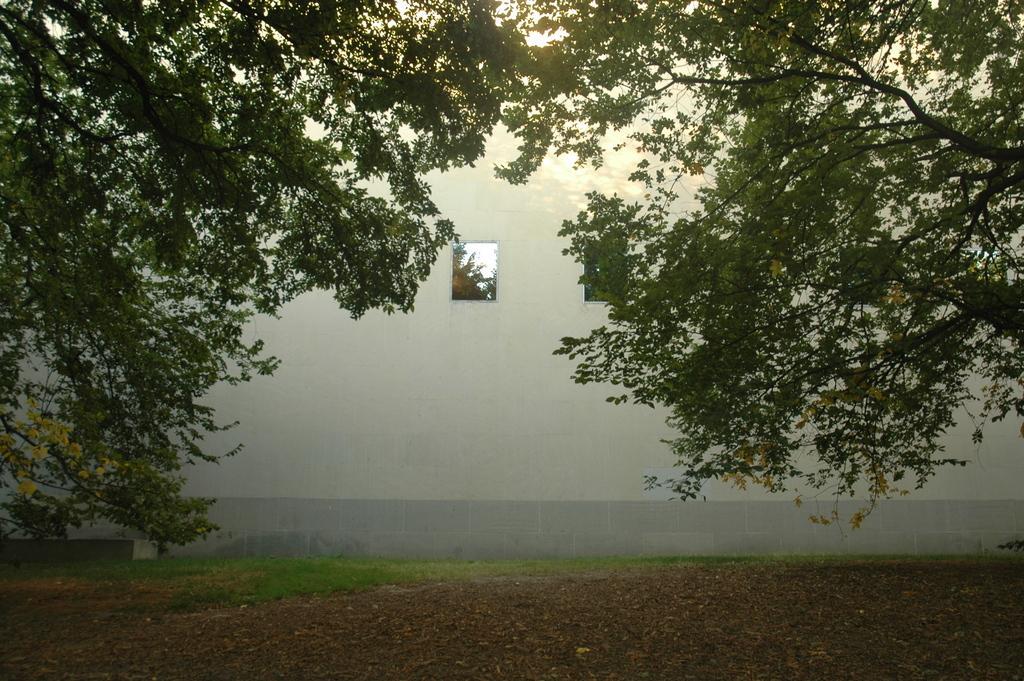Could you give a brief overview of what you see in this image? In this picture we can see trees, ground, grass, wall and window, through window we can see leaves and sky. 